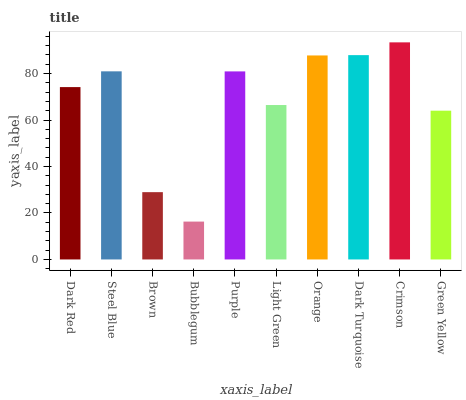Is Bubblegum the minimum?
Answer yes or no. Yes. Is Crimson the maximum?
Answer yes or no. Yes. Is Steel Blue the minimum?
Answer yes or no. No. Is Steel Blue the maximum?
Answer yes or no. No. Is Steel Blue greater than Dark Red?
Answer yes or no. Yes. Is Dark Red less than Steel Blue?
Answer yes or no. Yes. Is Dark Red greater than Steel Blue?
Answer yes or no. No. Is Steel Blue less than Dark Red?
Answer yes or no. No. Is Purple the high median?
Answer yes or no. Yes. Is Dark Red the low median?
Answer yes or no. Yes. Is Crimson the high median?
Answer yes or no. No. Is Crimson the low median?
Answer yes or no. No. 